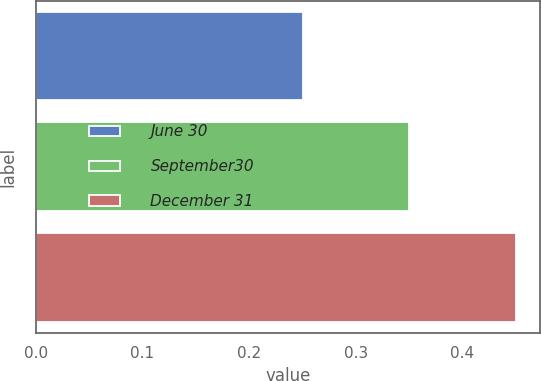<chart> <loc_0><loc_0><loc_500><loc_500><bar_chart><fcel>June 30<fcel>September30<fcel>December 31<nl><fcel>0.25<fcel>0.35<fcel>0.45<nl></chart> 